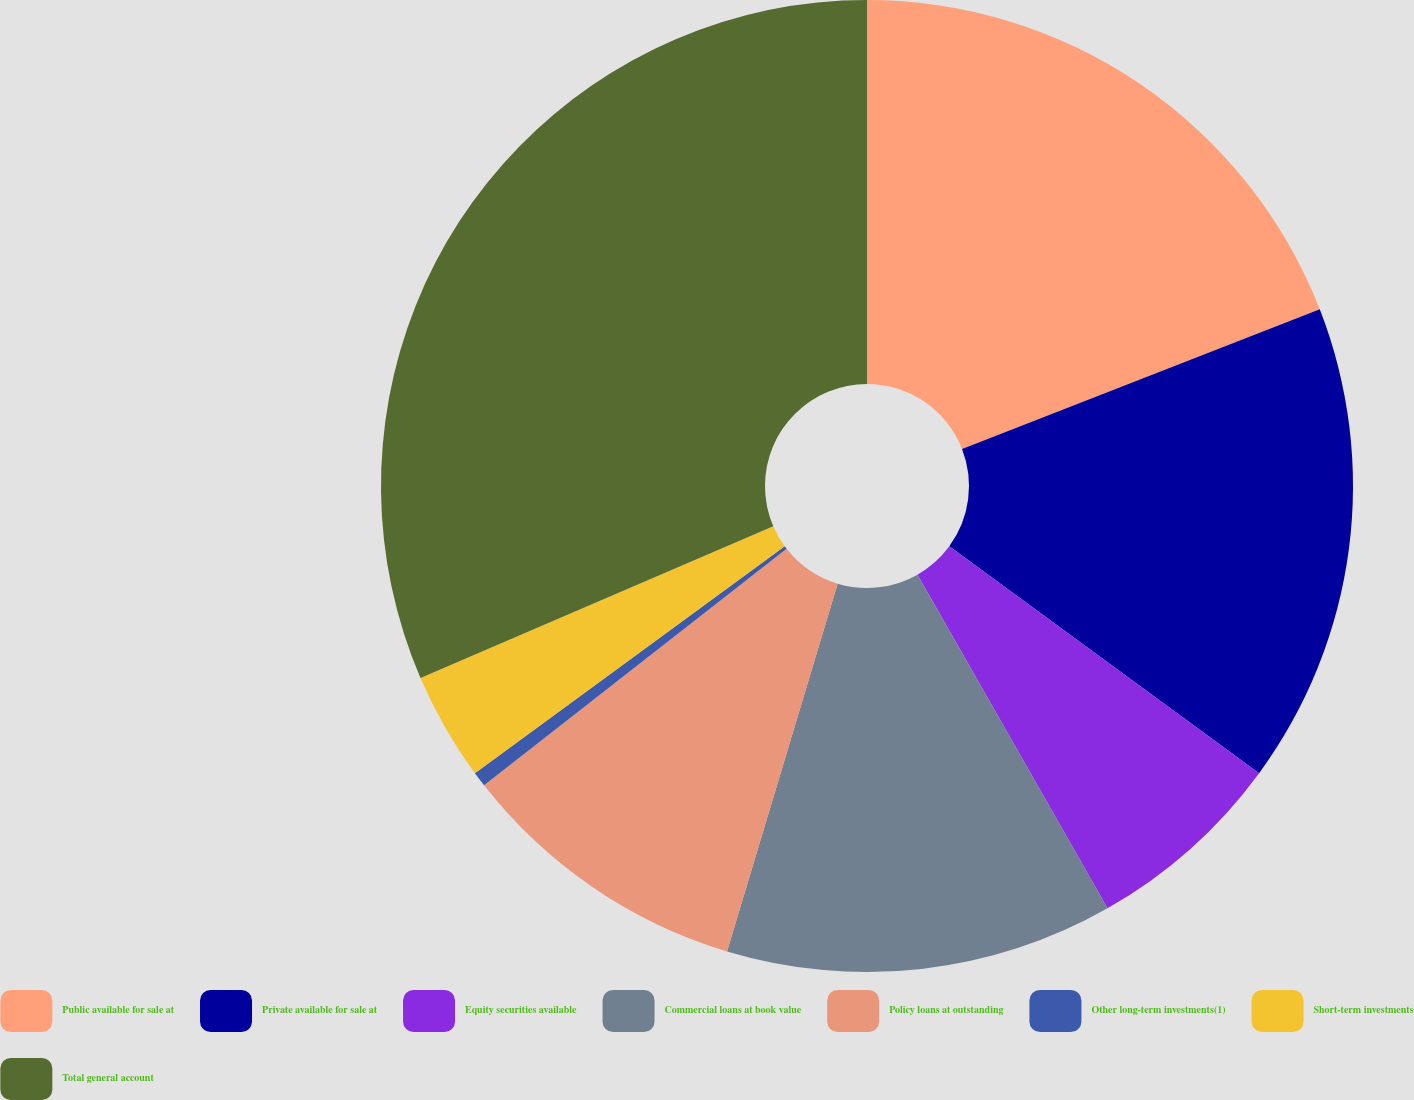Convert chart to OTSL. <chart><loc_0><loc_0><loc_500><loc_500><pie_chart><fcel>Public available for sale at<fcel>Private available for sale at<fcel>Equity securities available<fcel>Commercial loans at book value<fcel>Policy loans at outstanding<fcel>Other long-term investments(1)<fcel>Short-term investments<fcel>Total general account<nl><fcel>19.08%<fcel>15.98%<fcel>6.7%<fcel>12.89%<fcel>9.79%<fcel>0.5%<fcel>3.6%<fcel>31.46%<nl></chart> 